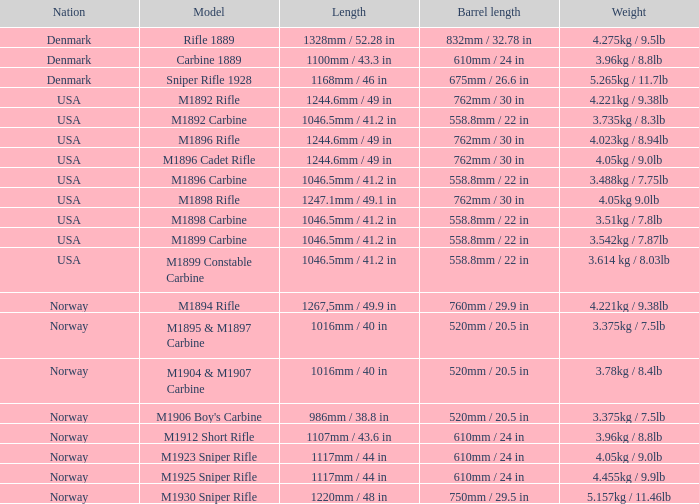What is Weight, when Length is 1168mm / 46 in? 5.265kg / 11.7lb. 